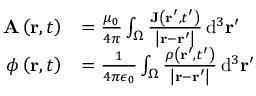Convert formula to latex. <formula><loc_0><loc_0><loc_500><loc_500>{ \begin{array} { r l } { A \left ( r , t \right ) } & { = { \frac { \mu _ { 0 } } { 4 \pi } } \int _ { \Omega } { \frac { J \left ( r ^ { \prime } , t ^ { \prime } \right ) } { \left | r - r ^ { \prime } \right | } } \, d ^ { 3 } r ^ { \prime } } \\ { \phi \left ( r , t \right ) } & { = { \frac { 1 } { 4 \pi \epsilon _ { 0 } } } \int _ { \Omega } { \frac { \rho \left ( r ^ { \prime } , t ^ { \prime } \right ) } { \left | r - r ^ { \prime } \right | } } \, d ^ { 3 } r ^ { \prime } } \end{array} }</formula> 